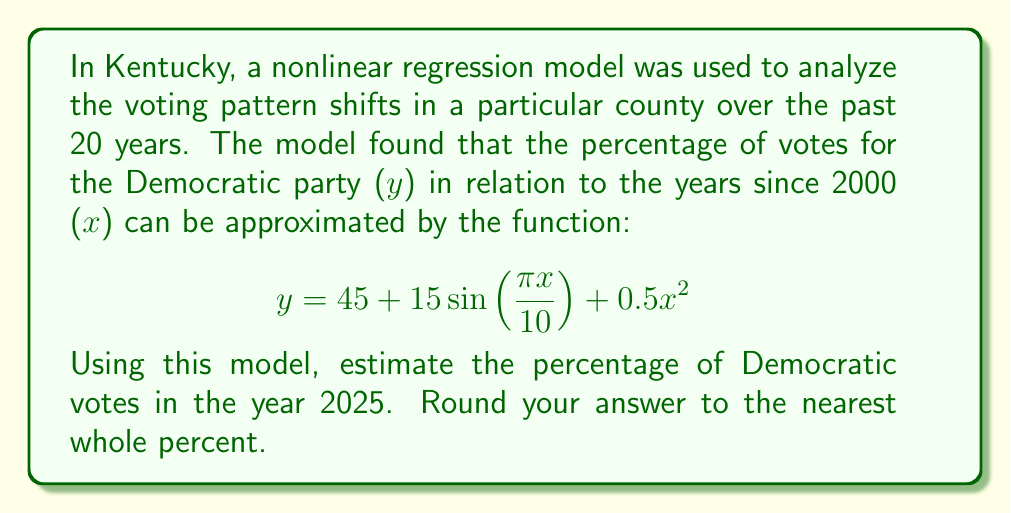Solve this math problem. Let's approach this step-by-step:

1) First, we need to determine the value of x for the year 2025.
   Since x represents the number of years since 2000:
   x = 2025 - 2000 = 25

2) Now, we can substitute this value into our function:
   $$y = 45 + 15\sin(\frac{\pi x}{10}) + 0.5x^2$$
   $$y = 45 + 15\sin(\frac{\pi (25)}{10}) + 0.5(25)^2$$

3) Let's calculate each part separately:
   a) $45$ is already a constant
   
   b) $15\sin(\frac{\pi (25)}{10})$:
      $\frac{\pi (25)}{10} = \frac{5\pi}{2} = 2.5\pi$
      $\sin(2.5\pi) = -1$
      So, $15\sin(\frac{\pi (25)}{10}) = 15 * (-1) = -15$
   
   c) $0.5(25)^2 = 0.5 * 625 = 312.5$

4) Now, let's add these parts:
   $y = 45 + (-15) + 312.5 = 342.5$

5) Rounding to the nearest whole percent:
   342.5 rounds to 343%

However, since percentages cannot exceed 100%, this result suggests that the model may not be reliable for extrapolation this far into the future. In reality, the percentage would be capped at 100%.
Answer: 100% 